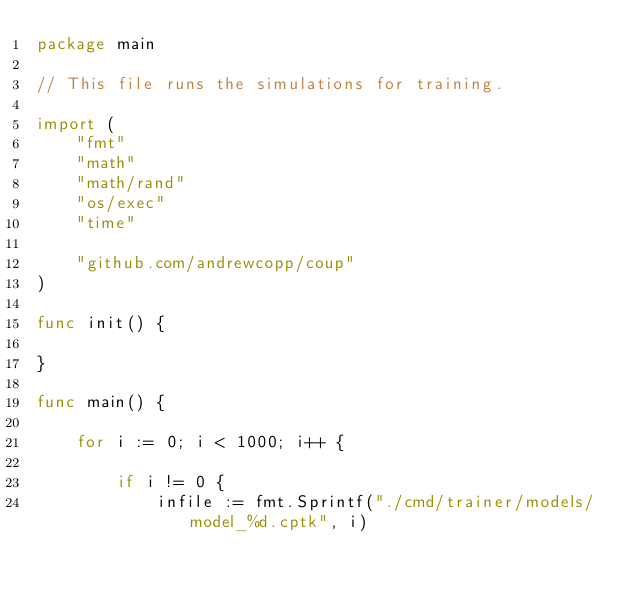<code> <loc_0><loc_0><loc_500><loc_500><_Go_>package main

// This file runs the simulations for training.

import (
	"fmt"
	"math"
	"math/rand"
	"os/exec"
	"time"

	"github.com/andrewcopp/coup"
)

func init() {

}

func main() {

	for i := 0; i < 1000; i++ {

		if i != 0 {
			infile := fmt.Sprintf("./cmd/trainer/models/model_%d.cptk", i)</code> 